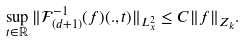<formula> <loc_0><loc_0><loc_500><loc_500>\sup _ { t \in \mathbb { R } } \| \mathcal { F } _ { ( d + 1 ) } ^ { - 1 } ( f ) ( . , t ) \| _ { L ^ { 2 } _ { x } } \leq C \| f \| _ { Z _ { k } } .</formula> 